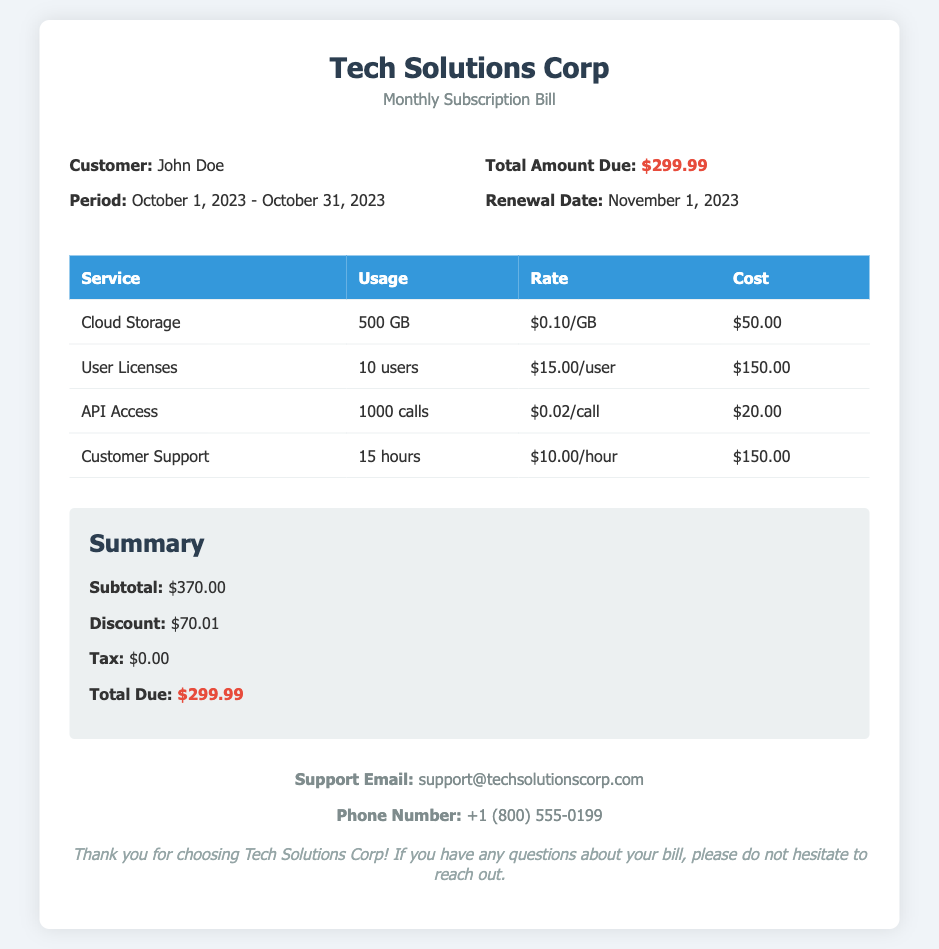What is the name of the customer? The bill identifies the customer as John Doe.
Answer: John Doe What is the period covered by this bill? The bill covers the period from October 1, 2023 to October 31, 2023.
Answer: October 1, 2023 - October 31, 2023 What is the total amount due? The document states that the total amount due is $299.99.
Answer: $299.99 When is the renewal date? According to the bill, the renewal date is November 1, 2023.
Answer: November 1, 2023 What is the cost of Cloud Storage? The bill shows that Cloud Storage costs $50.00.
Answer: $50.00 How many user licenses are included? The document specifies that there are 10 user licenses.
Answer: 10 users What is the discount amount applied? The discount amount applied to the bill is $70.01.
Answer: $70.01 What is the subtotal before discounts? The subtotal before discounts is stated as $370.00.
Answer: $370.00 How many hours of Customer Support were used? The bill lists 15 hours of Customer Support usage.
Answer: 15 hours 